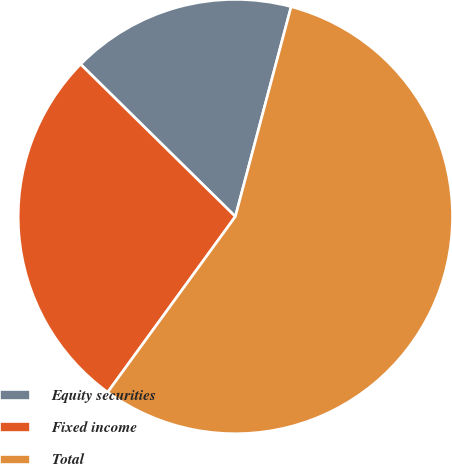<chart> <loc_0><loc_0><loc_500><loc_500><pie_chart><fcel>Equity securities<fcel>Fixed income<fcel>Total<nl><fcel>16.76%<fcel>27.37%<fcel>55.87%<nl></chart> 